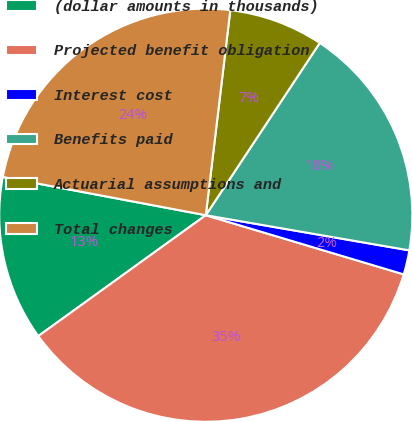<chart> <loc_0><loc_0><loc_500><loc_500><pie_chart><fcel>(dollar amounts in thousands)<fcel>Projected benefit obligation<fcel>Interest cost<fcel>Benefits paid<fcel>Actuarial assumptions and<fcel>Total changes<nl><fcel>12.91%<fcel>35.43%<fcel>1.9%<fcel>18.42%<fcel>7.41%<fcel>23.93%<nl></chart> 